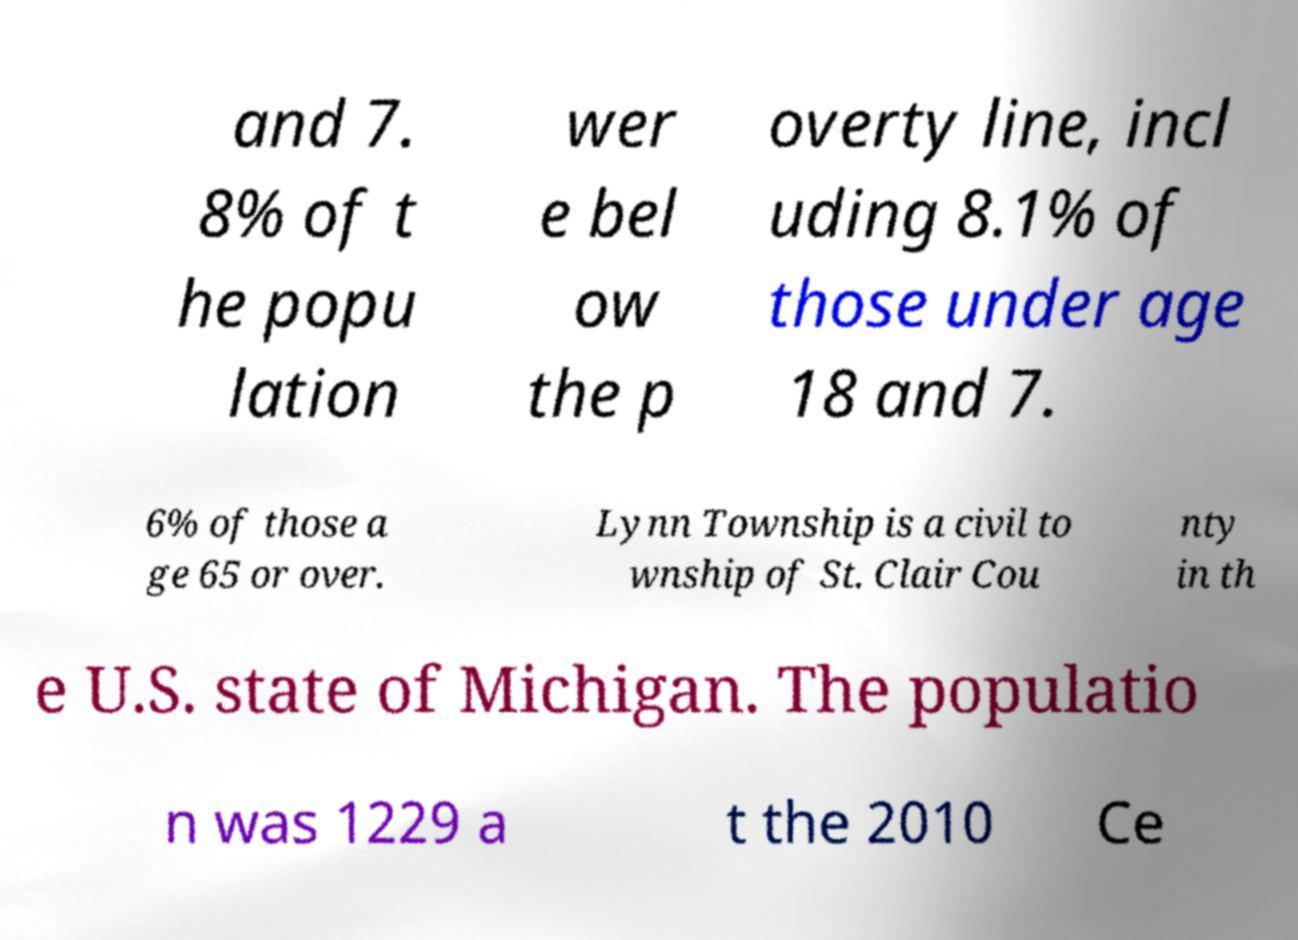There's text embedded in this image that I need extracted. Can you transcribe it verbatim? and 7. 8% of t he popu lation wer e bel ow the p overty line, incl uding 8.1% of those under age 18 and 7. 6% of those a ge 65 or over. Lynn Township is a civil to wnship of St. Clair Cou nty in th e U.S. state of Michigan. The populatio n was 1229 a t the 2010 Ce 